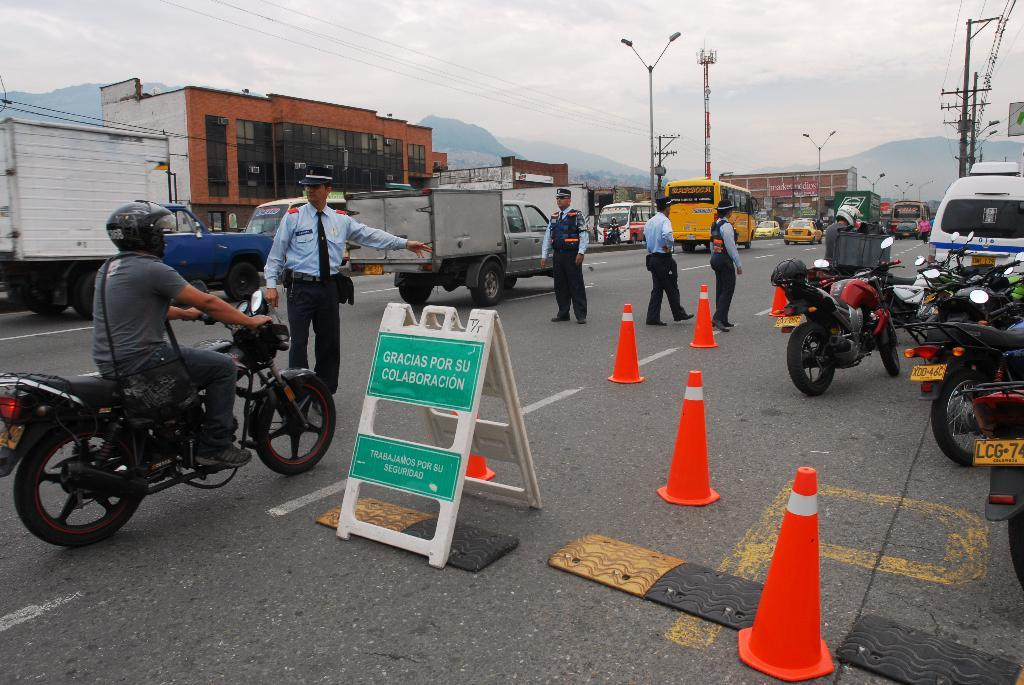What is the man doing on the left side of the image? The man is riding a bike on the left side of the image. What can be seen in the middle of the image? There are buildings in the middle of the image. What is happening on the road in the image? Other vehicles are moving on the road. What can be seen on the right side of the image? There are parked vehicles on the right side of the image. What type of grape is being discussed in the meeting on the right side of the image? There is no meeting or grape present in the image. What type of furniture can be seen in the image? There is no furniture visible in the image. 